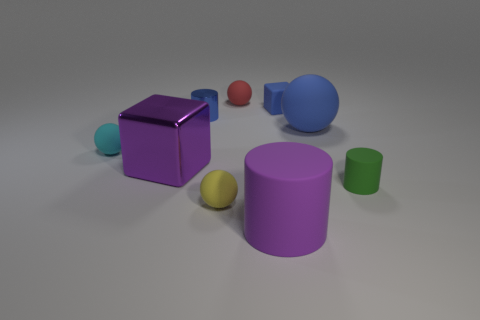How many objects are blue things or purple objects to the right of the small red rubber object?
Provide a succinct answer. 4. Do the matte sphere in front of the cyan rubber ball and the tiny shiny object have the same size?
Keep it short and to the point. Yes. There is a large thing behind the large purple metal block; what material is it?
Keep it short and to the point. Rubber. Are there the same number of tiny matte things on the left side of the purple metallic object and rubber things that are behind the large blue rubber object?
Give a very brief answer. No. What is the color of the big object that is the same shape as the small yellow object?
Provide a succinct answer. Blue. Is there anything else that is the same color as the large cylinder?
Provide a succinct answer. Yes. How many metal objects are either big brown blocks or blue spheres?
Provide a succinct answer. 0. Is the small rubber block the same color as the small matte cylinder?
Offer a very short reply. No. Is the number of small cyan matte things that are behind the small cyan ball greater than the number of big yellow rubber things?
Your response must be concise. No. What number of other objects are there of the same material as the purple cube?
Provide a succinct answer. 1. 